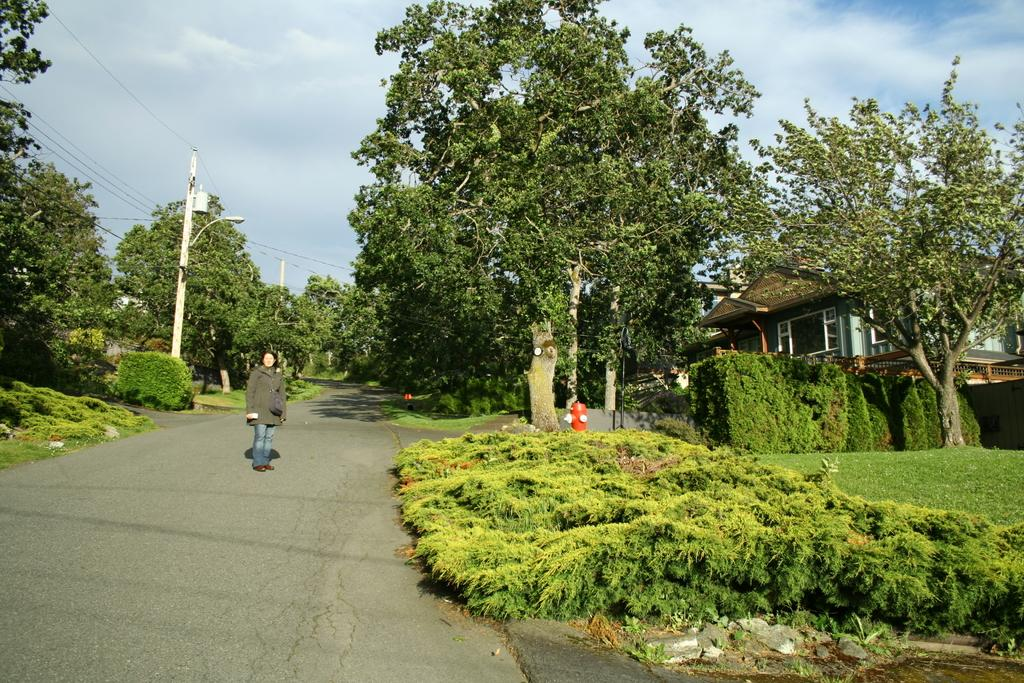What is the person in the image doing? The person is standing in the middle of the road. What can be seen in the background of the image? There are trees, plants, electric poles, and buildings in the image. What type of food is the person holding in the image? There is no food visible in the image. How many girls are present in the image? There is no mention of girls in the image, only a person standing in the middle of the road. 